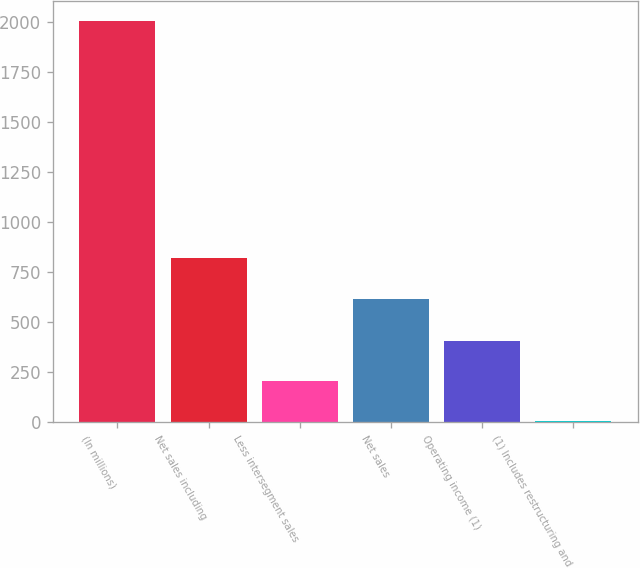Convert chart. <chart><loc_0><loc_0><loc_500><loc_500><bar_chart><fcel>(In millions)<fcel>Net sales including<fcel>Less intersegment sales<fcel>Net sales<fcel>Operating income (1)<fcel>(1) Includes restructuring and<nl><fcel>2007<fcel>818.78<fcel>204.48<fcel>618.5<fcel>404.76<fcel>4.2<nl></chart> 